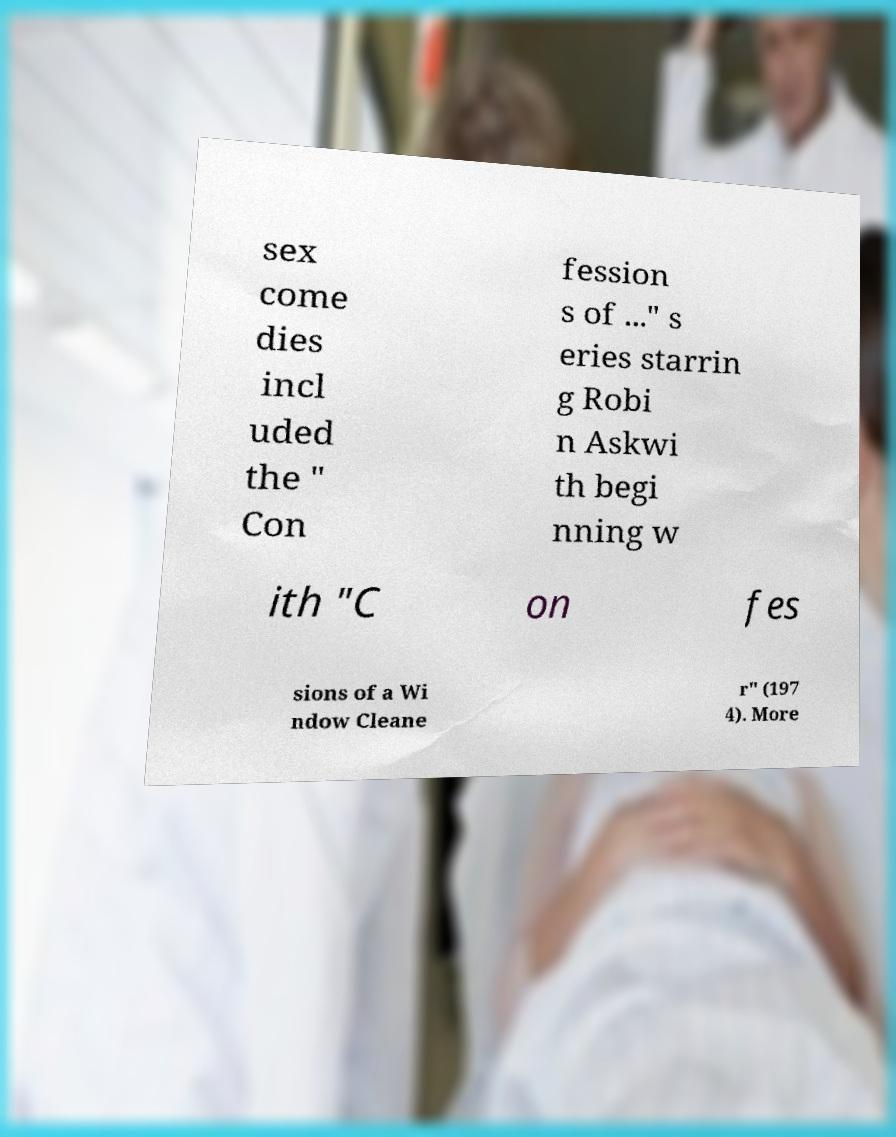There's text embedded in this image that I need extracted. Can you transcribe it verbatim? sex come dies incl uded the " Con fession s of ..." s eries starrin g Robi n Askwi th begi nning w ith "C on fes sions of a Wi ndow Cleane r" (197 4). More 